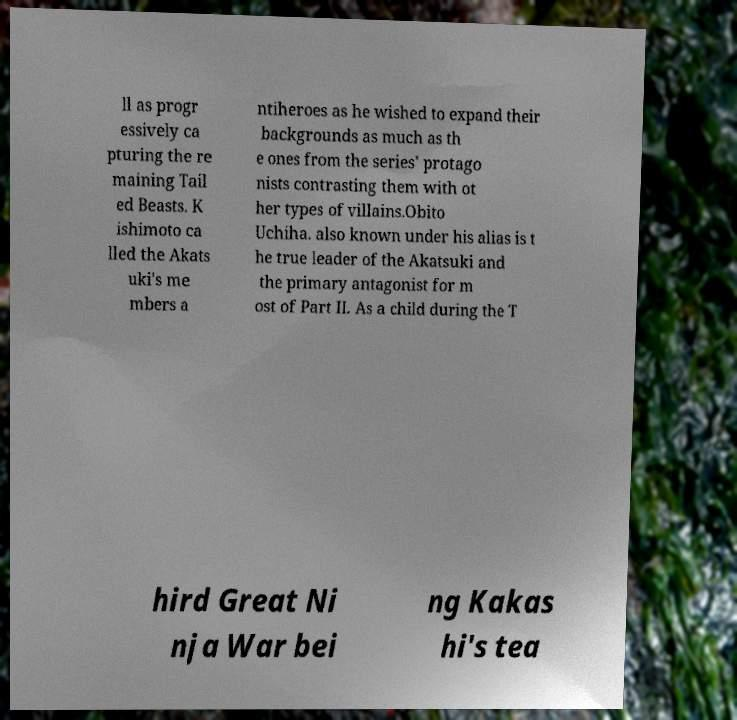Please identify and transcribe the text found in this image. ll as progr essively ca pturing the re maining Tail ed Beasts. K ishimoto ca lled the Akats uki's me mbers a ntiheroes as he wished to expand their backgrounds as much as th e ones from the series' protago nists contrasting them with ot her types of villains.Obito Uchiha. also known under his alias is t he true leader of the Akatsuki and the primary antagonist for m ost of Part II. As a child during the T hird Great Ni nja War bei ng Kakas hi's tea 